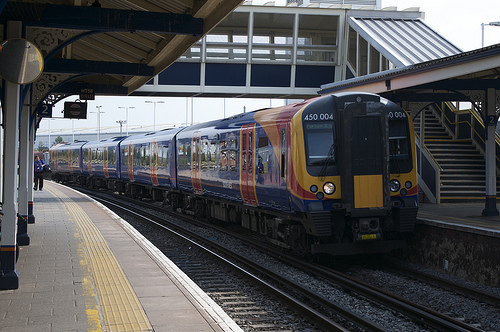Please provide the bounding box coordinate of the region this sentence describes: a brick in the ground. The specified area for the brick in the ground can be seen at [0.06, 0.75, 0.17, 0.8]. This small, detailed aspect of the station's construction adds to the overall aesthetic and structural integrity. 